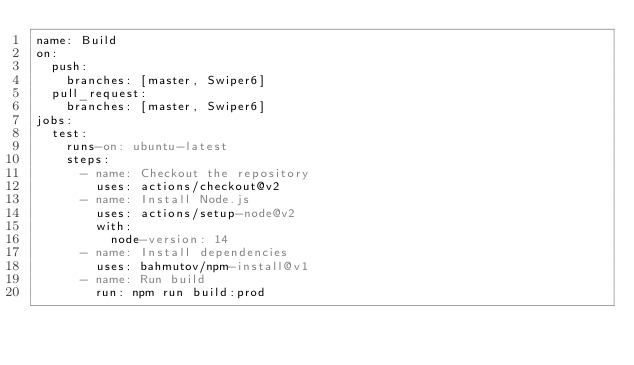Convert code to text. <code><loc_0><loc_0><loc_500><loc_500><_YAML_>name: Build
on:
  push:
    branches: [master, Swiper6]
  pull_request:
    branches: [master, Swiper6]
jobs:
  test:
    runs-on: ubuntu-latest
    steps:
      - name: Checkout the repository
        uses: actions/checkout@v2
      - name: Install Node.js
        uses: actions/setup-node@v2
        with:
          node-version: 14
      - name: Install dependencies
        uses: bahmutov/npm-install@v1
      - name: Run build
        run: npm run build:prod
</code> 